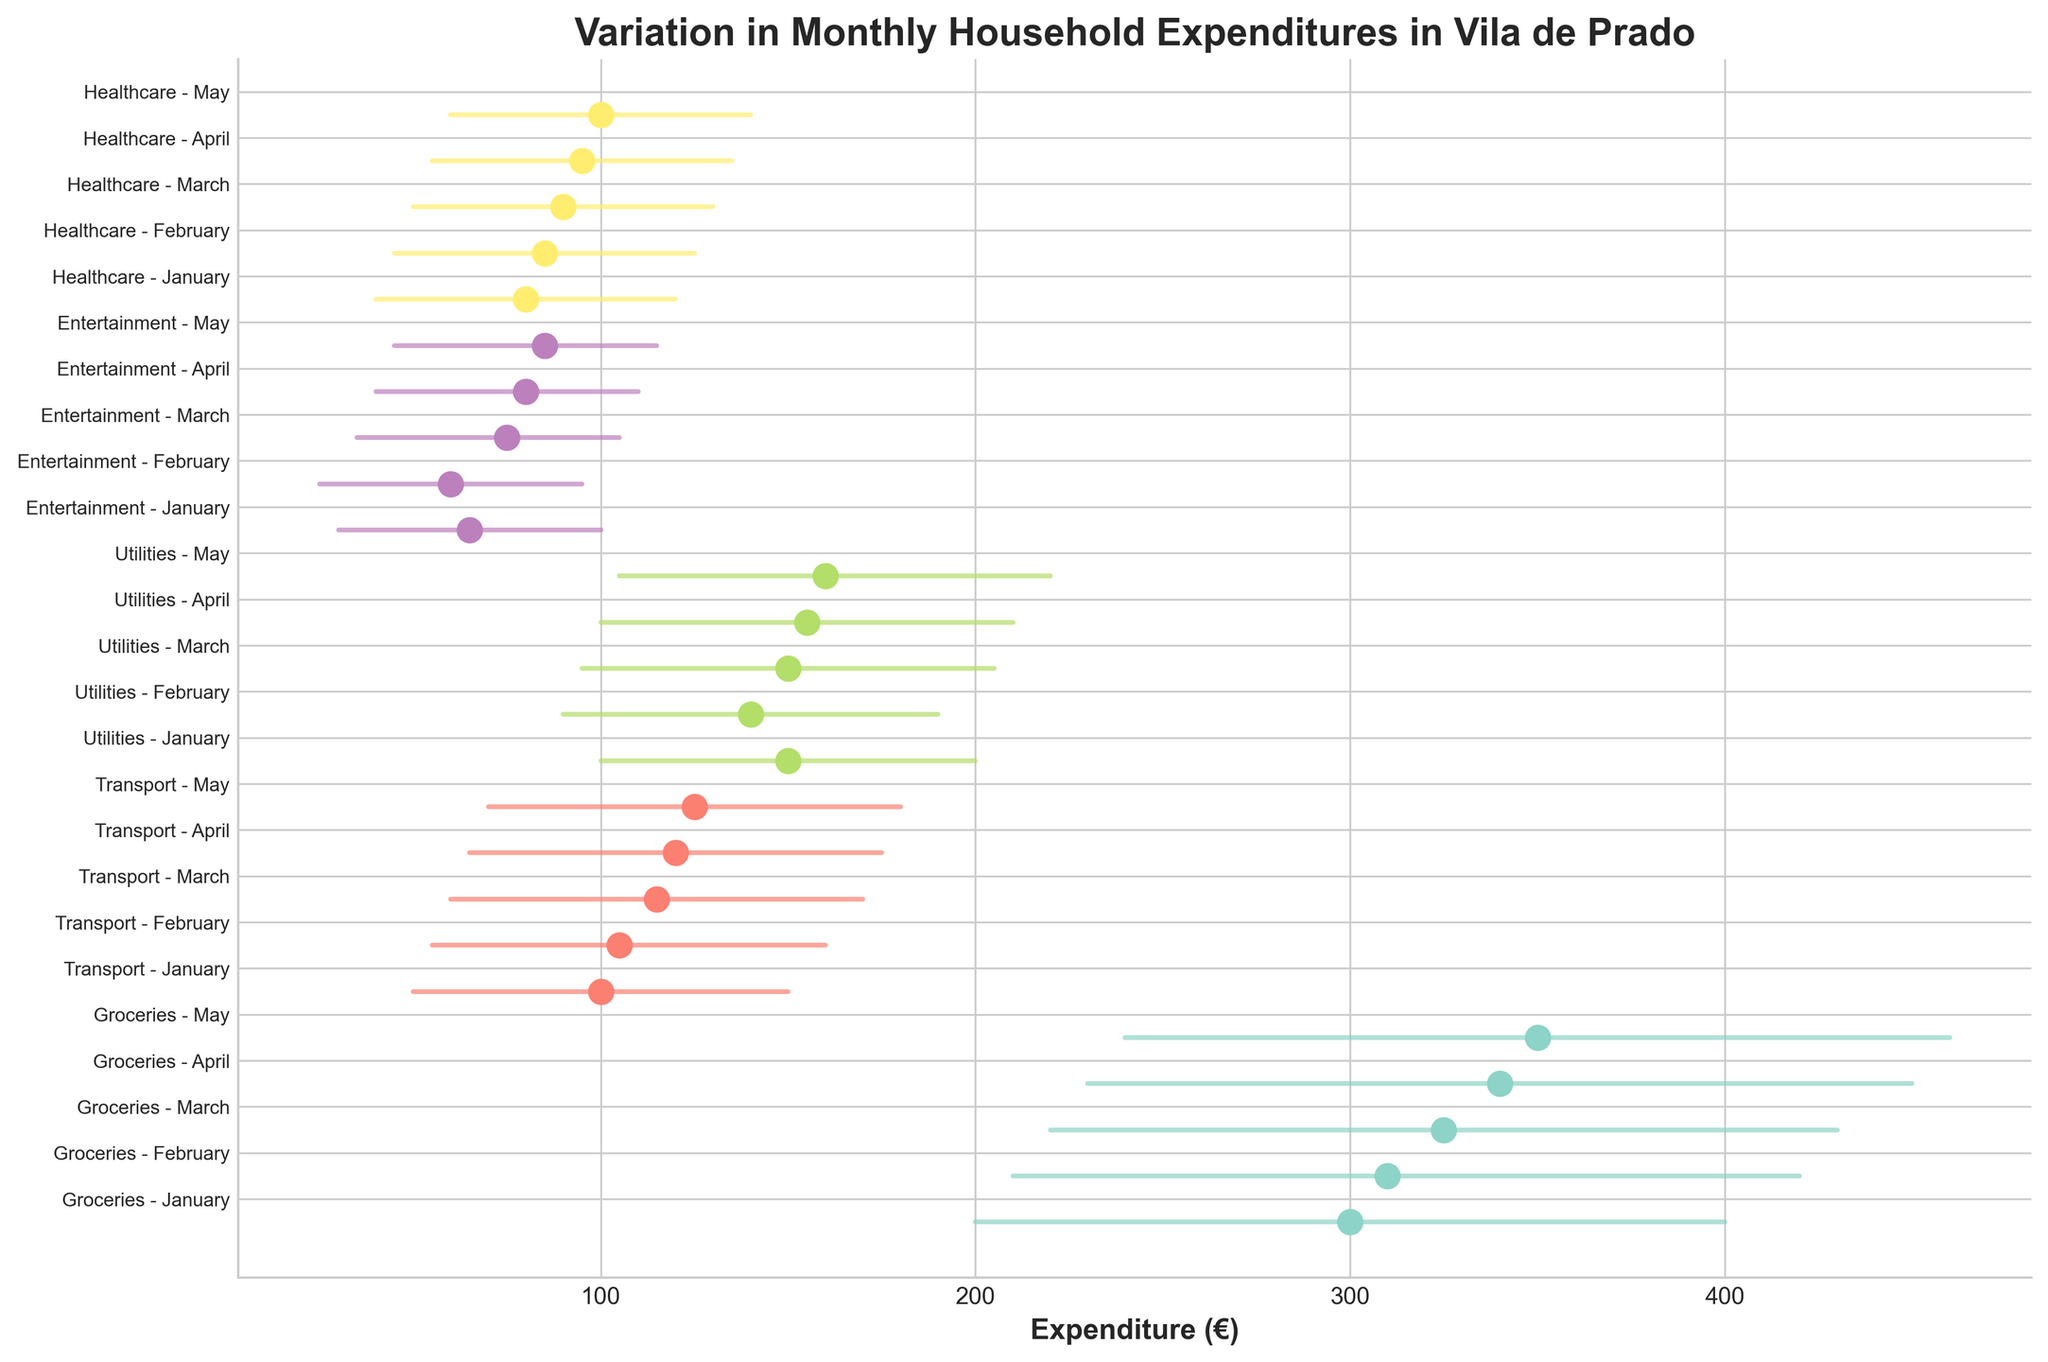What's the title of the plot? The title is prominently displayed at the top of the plot. It summarizes the main subject of the visualization.
Answer: Variation in Monthly Household Expenditures in Vila de Prado Which category has the highest maximum expenditure in any month? Look for the category with the highest furthest right endpoint for any month. Groceries in May shows the highest maximum expenditure value.
Answer: Groceries What is the median expenditure for Transport in March? Locate the dot corresponding to Transport in March. The dot represents the median value.
Answer: 115 How does the range of Utilities expenditure in January compare to May? For both months, check the distance between the minimum and maximum expenditures for Utilities. January has a range of [100, 200] and May has a range of [105, 220]. Calculate the differences: May has a slightly wider range.
Answer: Wider in May Which month shows the lowest minimum expenditure for Entertainment? Look for the month where the minimum expenditure for Entertainment is the lowest on the leftmost side.
Answer: February Is the median expenditure for Healthcare increasing from January to May? Observe the dots representing the median expenditure for Healthcare from January to May. They seem to increase sequentially. Verify actual values from the data: 80, 85, 90, 95, 100.
Answer: Yes What’s the difference between the max and min expenditure for Groceries in April? Check the max and min lines for Groceries in April and subtract the min from the max: 450 - 230.
Answer: 220 Which category shows the smallest range of expenditures in February? Determine the length of the lines (representing expenditure ranges) for each category in February. Transport has the range of [55, 160], a lower range compared to others.
Answer: Entertainment Does any category in March have the same maximum expenditure as its median? Inspect March's categories and compare the position of the dot (median) relative to the far right endpoint (maximum). None aligns exactly.
Answer: No 